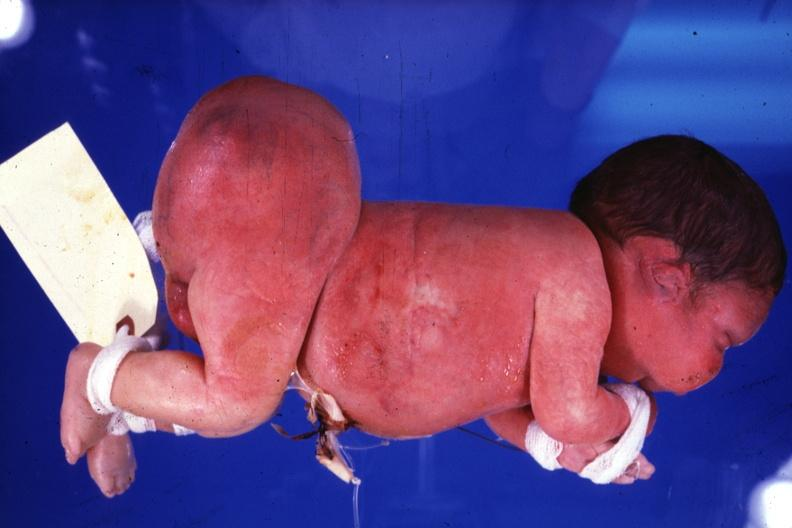s macerated stillborn present?
Answer the question using a single word or phrase. No 